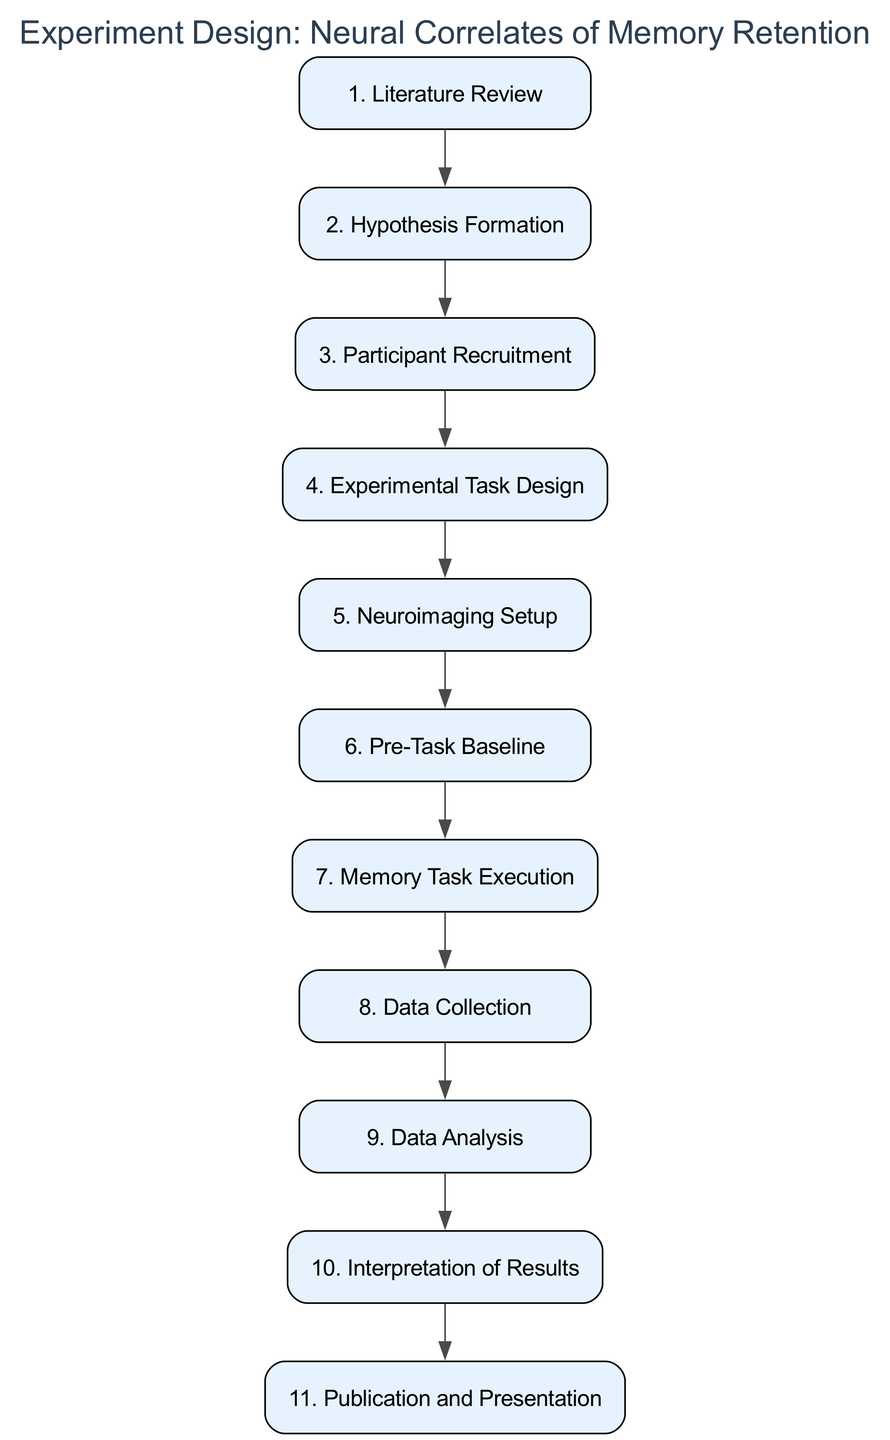What is the first step in the experiment design? The first step in the diagram is identified by the first node labeled "1. Literature Review". This indicates that the initial action in the flow of the experiment design involves reviewing existing studies.
Answer: Literature Review How many total steps are there in the experiment design? To determine the total number of steps, we count the individual nodes in the diagram. There are 11 steps listed from "1. Literature Review" to "11. Publication and Presentation".
Answer: 11 What is the last step in the experiment design? The last step is indicated by the final node which is labeled "11. Publication and Presentation". This signifies that the final action taken in the flow is to prepare and present findings.
Answer: Publication and Presentation Which step directly follows "Participant Recruitment"? In the flow of the experiment design, "Participant Recruitment" is marked as step 3, and it is followed directly by "Experimental Task Design", which is step 4.
Answer: Experimental Task Design What is the hypothesis formation focused on? The step titled "Hypothesis Formation", which is step 2, states the focus is on formulating a hypothesis regarding how neural circuits affect memory retention, specifically mentioning the hippocampus.
Answer: Neural circuits Which steps involve data collection or analysis? Analyzing the flow, steps that involve data collection or processing include "Data Collection" (step 8) and "Data Analysis" (step 9). Both involve gathering and examining data regarding memory tasks.
Answer: Data Collection, Data Analysis What is the purpose of the "Pre-Task Baseline"? The "Pre-Task Baseline" in step 6 is designed to record baseline neural activity to account for individual differences in brain activity before the execution of memory tasks.
Answer: Account for differences Which step must be completed before "Memory Task Execution"? Looking at the sequential flow, "Data Collection" (step 8) clearly requires "Memory Task Execution" (step 7) to be concluded, as participants must complete the memory tasks before their performance data is recorded.
Answer: Experimental Task Design What method is used for neuroimaging in the experiment? The method specified in the "Neuroimaging Setup," which is step 5, indicates that the experiment will utilize fMRI or EEG to capture neural activity during memory tasks.
Answer: fMRI or EEG 